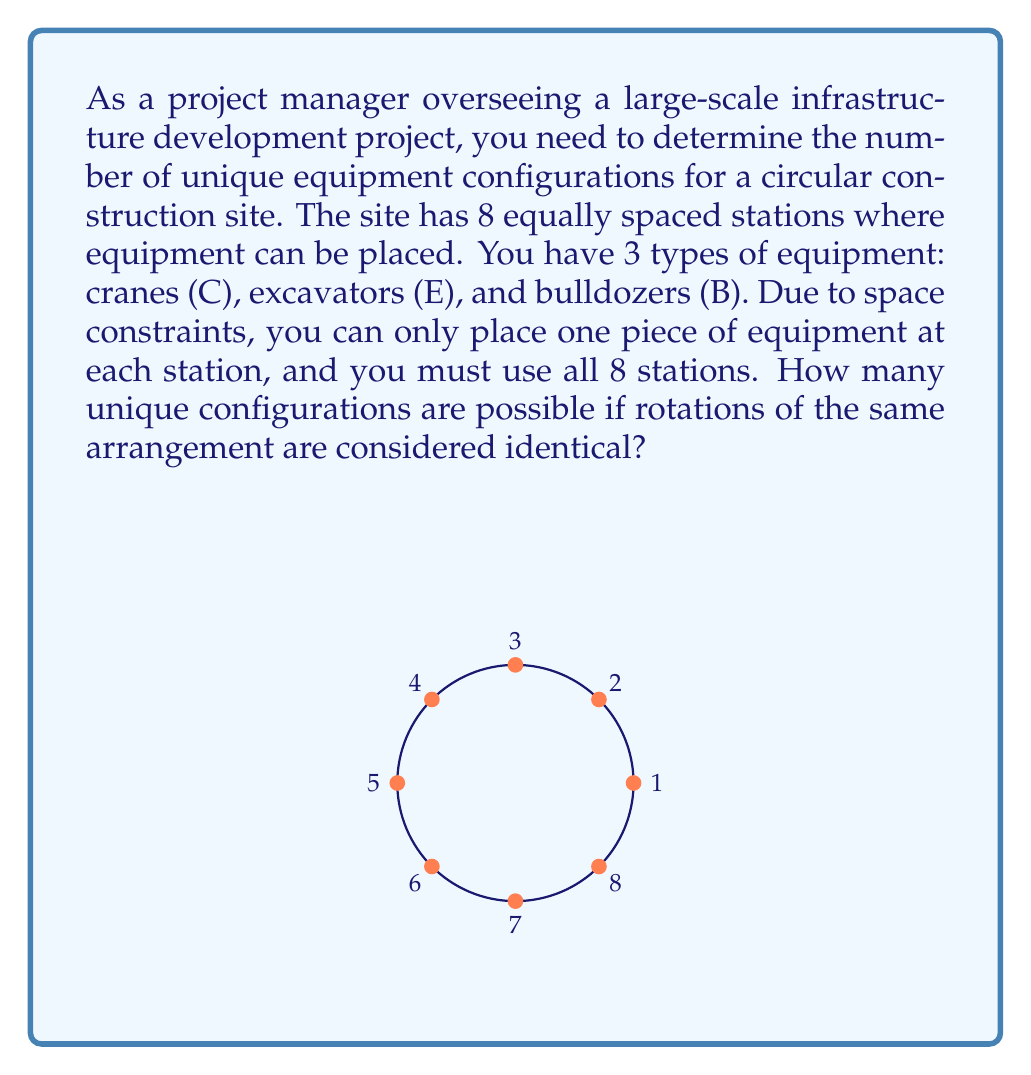Show me your answer to this math problem. To solve this problem, we can use the concept of cyclic groups from Ring theory. Here's a step-by-step explanation:

1) First, we need to understand that this problem involves a cyclic group of order 8, as we have 8 stations arranged in a circle.

2) The total number of ways to arrange 3 types of equipment in 8 stations without considering rotations would be $3^8 = 6561$.

3) However, we need to account for rotations. In a cyclic group of order 8, each arrangement can be rotated 8 ways to produce equivalent configurations.

4) To find the number of unique configurations, we can use Burnside's lemma, which states:

   $$ |X/G| = \frac{1}{|G|} \sum_{g \in G} |X^g| $$

   Where $|X/G|$ is the number of orbits (unique configurations), $|G|$ is the order of the group (8 in this case), and $|X^g|$ is the number of elements fixed by each group action.

5) In our case:
   - The identity rotation fixes all $3^8$ configurations
   - Rotations by 1, 3, 5, or 7 positions fix no configurations
   - Rotation by 2 positions fixes $3^4 = 81$ configurations
   - Rotation by 4 positions fixes $3^2 = 9$ configurations
   - Rotation by 6 positions fixes $3^4 = 81$ configurations

6) Applying Burnside's lemma:

   $$ |X/G| = \frac{1}{8} (3^8 + 0 + 3^4 + 0 + 3^2 + 0 + 3^4 + 0) $$
   $$ = \frac{1}{8} (6561 + 81 + 9 + 81) $$
   $$ = \frac{6732}{8} = 841.5 $$

7) Since we can't have a fractional number of configurations, we round down to 841.

Therefore, there are 841 unique equipment configurations possible.
Answer: 841 